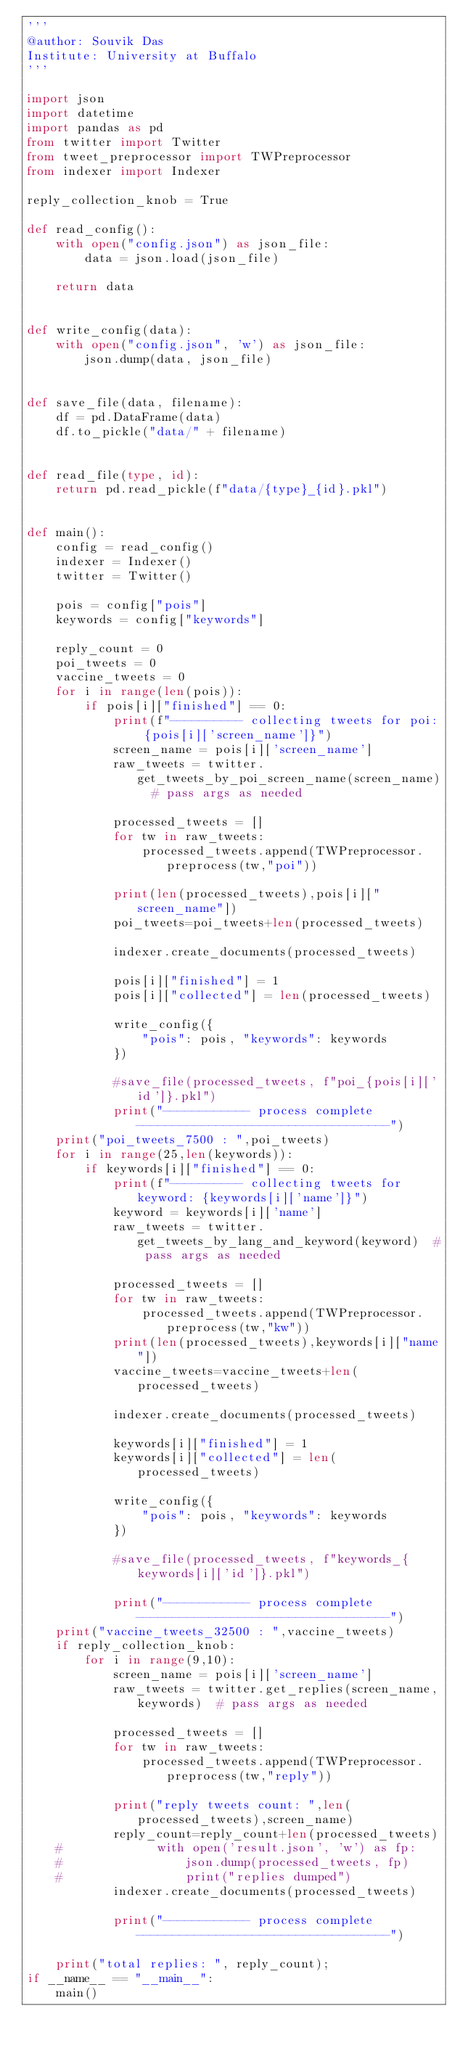Convert code to text. <code><loc_0><loc_0><loc_500><loc_500><_Python_>'''
@author: Souvik Das
Institute: University at Buffalo
'''

import json
import datetime
import pandas as pd
from twitter import Twitter
from tweet_preprocessor import TWPreprocessor
from indexer import Indexer

reply_collection_knob = True

def read_config():
    with open("config.json") as json_file:
        data = json.load(json_file)

    return data


def write_config(data):
    with open("config.json", 'w') as json_file:
        json.dump(data, json_file)


def save_file(data, filename):
    df = pd.DataFrame(data)
    df.to_pickle("data/" + filename)


def read_file(type, id):
    return pd.read_pickle(f"data/{type}_{id}.pkl")


def main():
    config = read_config()
    indexer = Indexer()
    twitter = Twitter()

    pois = config["pois"]
    keywords = config["keywords"]
    
    reply_count = 0
    poi_tweets = 0
    vaccine_tweets = 0
    for i in range(len(pois)):
        if pois[i]["finished"] == 0:
            print(f"---------- collecting tweets for poi: {pois[i]['screen_name']}")
            screen_name = pois[i]['screen_name']
            raw_tweets = twitter.get_tweets_by_poi_screen_name(screen_name)  # pass args as needed

            processed_tweets = []
            for tw in raw_tweets:
                processed_tweets.append(TWPreprocessor.preprocess(tw,"poi"))

            print(len(processed_tweets),pois[i]["screen_name"])
            poi_tweets=poi_tweets+len(processed_tweets)
            
            indexer.create_documents(processed_tweets)

            pois[i]["finished"] = 1
            pois[i]["collected"] = len(processed_tweets)

            write_config({
                "pois": pois, "keywords": keywords
            })

            #save_file(processed_tweets, f"poi_{pois[i]['id']}.pkl")
            print("------------ process complete -----------------------------------")
    print("poi_tweets_7500 : ",poi_tweets)
    for i in range(25,len(keywords)):
        if keywords[i]["finished"] == 0:
            print(f"---------- collecting tweets for keyword: {keywords[i]['name']}")
            keyword = keywords[i]['name']
            raw_tweets = twitter.get_tweets_by_lang_and_keyword(keyword)  # pass args as needed

            processed_tweets = []
            for tw in raw_tweets:
                processed_tweets.append(TWPreprocessor.preprocess(tw,"kw"))
            print(len(processed_tweets),keywords[i]["name"])
            vaccine_tweets=vaccine_tweets+len(processed_tweets)
            
            indexer.create_documents(processed_tweets)

            keywords[i]["finished"] = 1
            keywords[i]["collected"] = len(processed_tweets)

            write_config({
                "pois": pois, "keywords": keywords
            })

            #save_file(processed_tweets, f"keywords_{keywords[i]['id']}.pkl")

            print("------------ process complete -----------------------------------")
    print("vaccine_tweets_32500 : ",vaccine_tweets)
    if reply_collection_knob:
        for i in range(9,10):
            screen_name = pois[i]['screen_name']
            raw_tweets = twitter.get_replies(screen_name,keywords)  # pass args as needed

            processed_tweets = []
            for tw in raw_tweets:
                processed_tweets.append(TWPreprocessor.preprocess(tw,"reply"))

            print("reply tweets count: ",len(processed_tweets),screen_name)
            reply_count=reply_count+len(processed_tweets)
    #             with open('result.json', 'w') as fp:
    #                 json.dump(processed_tweets, fp)
    #                 print("replies dumped")
            indexer.create_documents(processed_tweets)

            print("------------ process complete -----------------------------------")

    print("total replies: ", reply_count);
if __name__ == "__main__":
    main()
</code> 